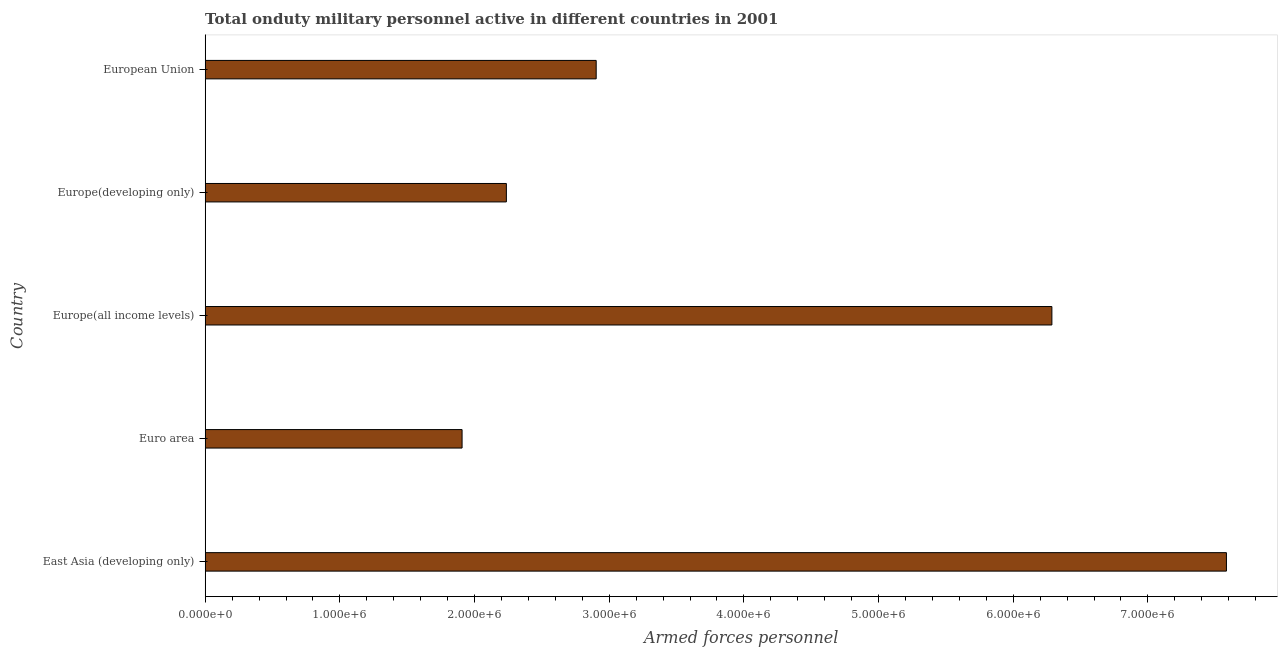What is the title of the graph?
Make the answer very short. Total onduty military personnel active in different countries in 2001. What is the label or title of the X-axis?
Keep it short and to the point. Armed forces personnel. What is the label or title of the Y-axis?
Your answer should be very brief. Country. What is the number of armed forces personnel in East Asia (developing only)?
Your answer should be very brief. 7.58e+06. Across all countries, what is the maximum number of armed forces personnel?
Keep it short and to the point. 7.58e+06. Across all countries, what is the minimum number of armed forces personnel?
Offer a very short reply. 1.91e+06. In which country was the number of armed forces personnel maximum?
Make the answer very short. East Asia (developing only). What is the sum of the number of armed forces personnel?
Give a very brief answer. 2.09e+07. What is the difference between the number of armed forces personnel in East Asia (developing only) and European Union?
Keep it short and to the point. 4.68e+06. What is the average number of armed forces personnel per country?
Your response must be concise. 4.18e+06. What is the median number of armed forces personnel?
Your answer should be very brief. 2.90e+06. In how many countries, is the number of armed forces personnel greater than 4000000 ?
Offer a very short reply. 2. What is the ratio of the number of armed forces personnel in East Asia (developing only) to that in Euro area?
Your response must be concise. 3.98. What is the difference between the highest and the second highest number of armed forces personnel?
Offer a terse response. 1.30e+06. What is the difference between the highest and the lowest number of armed forces personnel?
Your answer should be compact. 5.68e+06. Are all the bars in the graph horizontal?
Give a very brief answer. Yes. How many countries are there in the graph?
Keep it short and to the point. 5. What is the difference between two consecutive major ticks on the X-axis?
Make the answer very short. 1.00e+06. Are the values on the major ticks of X-axis written in scientific E-notation?
Your answer should be very brief. Yes. What is the Armed forces personnel of East Asia (developing only)?
Give a very brief answer. 7.58e+06. What is the Armed forces personnel of Euro area?
Make the answer very short. 1.91e+06. What is the Armed forces personnel in Europe(all income levels)?
Offer a very short reply. 6.29e+06. What is the Armed forces personnel in Europe(developing only)?
Offer a very short reply. 2.24e+06. What is the Armed forces personnel of European Union?
Ensure brevity in your answer.  2.90e+06. What is the difference between the Armed forces personnel in East Asia (developing only) and Euro area?
Offer a terse response. 5.68e+06. What is the difference between the Armed forces personnel in East Asia (developing only) and Europe(all income levels)?
Keep it short and to the point. 1.30e+06. What is the difference between the Armed forces personnel in East Asia (developing only) and Europe(developing only)?
Your answer should be compact. 5.35e+06. What is the difference between the Armed forces personnel in East Asia (developing only) and European Union?
Offer a terse response. 4.68e+06. What is the difference between the Armed forces personnel in Euro area and Europe(all income levels)?
Provide a succinct answer. -4.38e+06. What is the difference between the Armed forces personnel in Euro area and Europe(developing only)?
Make the answer very short. -3.29e+05. What is the difference between the Armed forces personnel in Euro area and European Union?
Your answer should be very brief. -9.96e+05. What is the difference between the Armed forces personnel in Europe(all income levels) and Europe(developing only)?
Your answer should be very brief. 4.05e+06. What is the difference between the Armed forces personnel in Europe(all income levels) and European Union?
Provide a short and direct response. 3.38e+06. What is the difference between the Armed forces personnel in Europe(developing only) and European Union?
Provide a succinct answer. -6.67e+05. What is the ratio of the Armed forces personnel in East Asia (developing only) to that in Euro area?
Give a very brief answer. 3.98. What is the ratio of the Armed forces personnel in East Asia (developing only) to that in Europe(all income levels)?
Your response must be concise. 1.21. What is the ratio of the Armed forces personnel in East Asia (developing only) to that in Europe(developing only)?
Offer a very short reply. 3.39. What is the ratio of the Armed forces personnel in East Asia (developing only) to that in European Union?
Provide a succinct answer. 2.61. What is the ratio of the Armed forces personnel in Euro area to that in Europe(all income levels)?
Offer a terse response. 0.3. What is the ratio of the Armed forces personnel in Euro area to that in Europe(developing only)?
Your answer should be compact. 0.85. What is the ratio of the Armed forces personnel in Euro area to that in European Union?
Provide a short and direct response. 0.66. What is the ratio of the Armed forces personnel in Europe(all income levels) to that in Europe(developing only)?
Keep it short and to the point. 2.81. What is the ratio of the Armed forces personnel in Europe(all income levels) to that in European Union?
Keep it short and to the point. 2.17. What is the ratio of the Armed forces personnel in Europe(developing only) to that in European Union?
Keep it short and to the point. 0.77. 